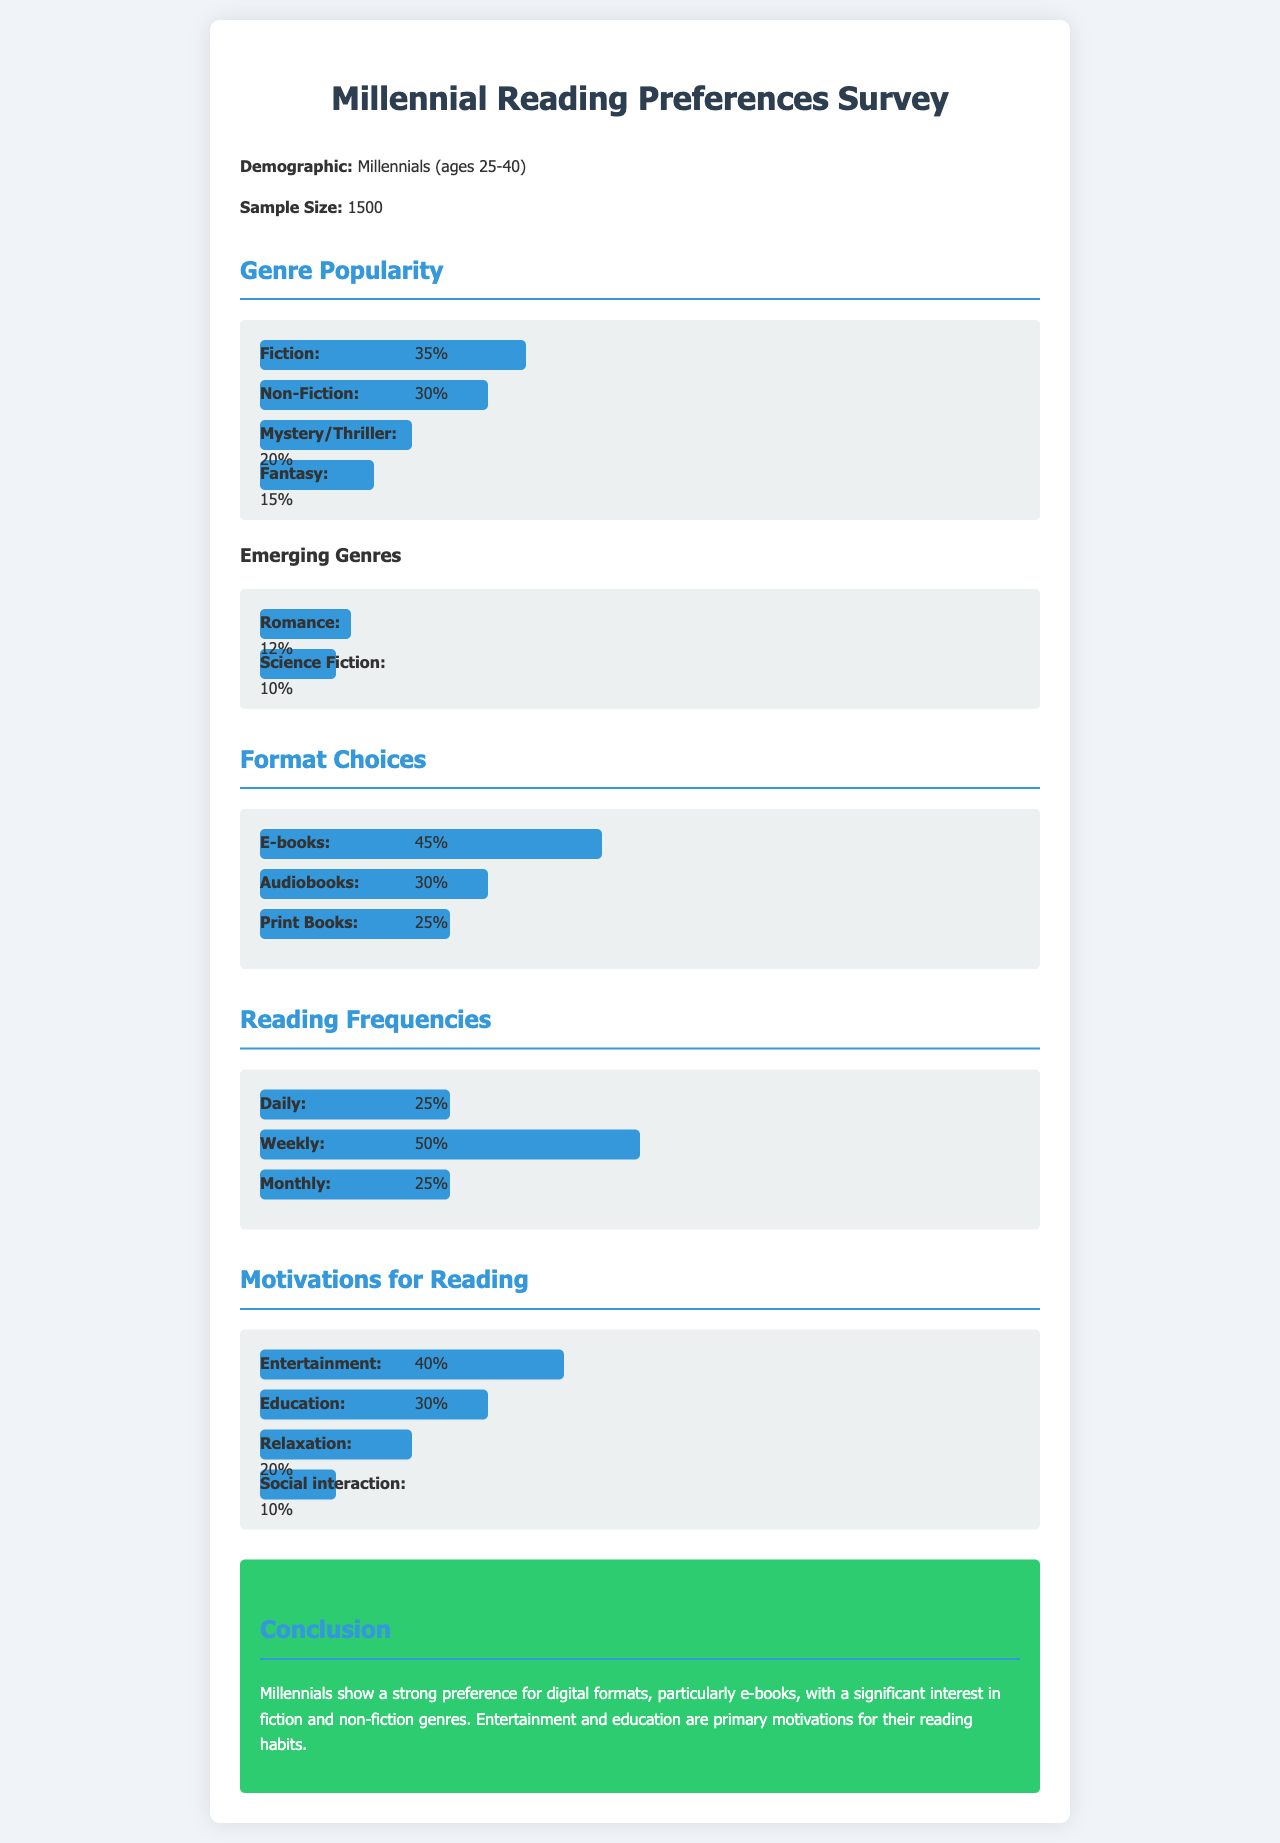what is the sample size of the survey? The sample size of the survey is mentioned as 1500.
Answer: 1500 which genre is the most popular among millennials? The most popular genre among millennials is indicated as Fiction with 35%.
Answer: Fiction what percentage of millennials prefer e-books? The document states that 45% of millennials prefer e-books.
Answer: 45% how often do 50% of millennials read? The survey indicates that 50% of millennials read weekly.
Answer: Weekly what is the primary motivation for reading according to the survey? The primary motivation for reading highlighted in the document is Entertainment at 40%.
Answer: Entertainment what percentage of respondents enjoy Romance as a genre? The survey shows that 12% of respondents enjoy Romance.
Answer: 12% which format has the least preference among millennials? The format with the least preference among millennials is Print Books at 25%.
Answer: Print Books how many genres are considered emerging in the survey? The document mentions two emerging genres: Romance and Science Fiction.
Answer: Two what is the main conclusion drawn from the survey results? The conclusion states that millennials prefer digital formats, especially e-books, with a focus on fiction and non-fiction genres.
Answer: Digital formats, especially e-books 